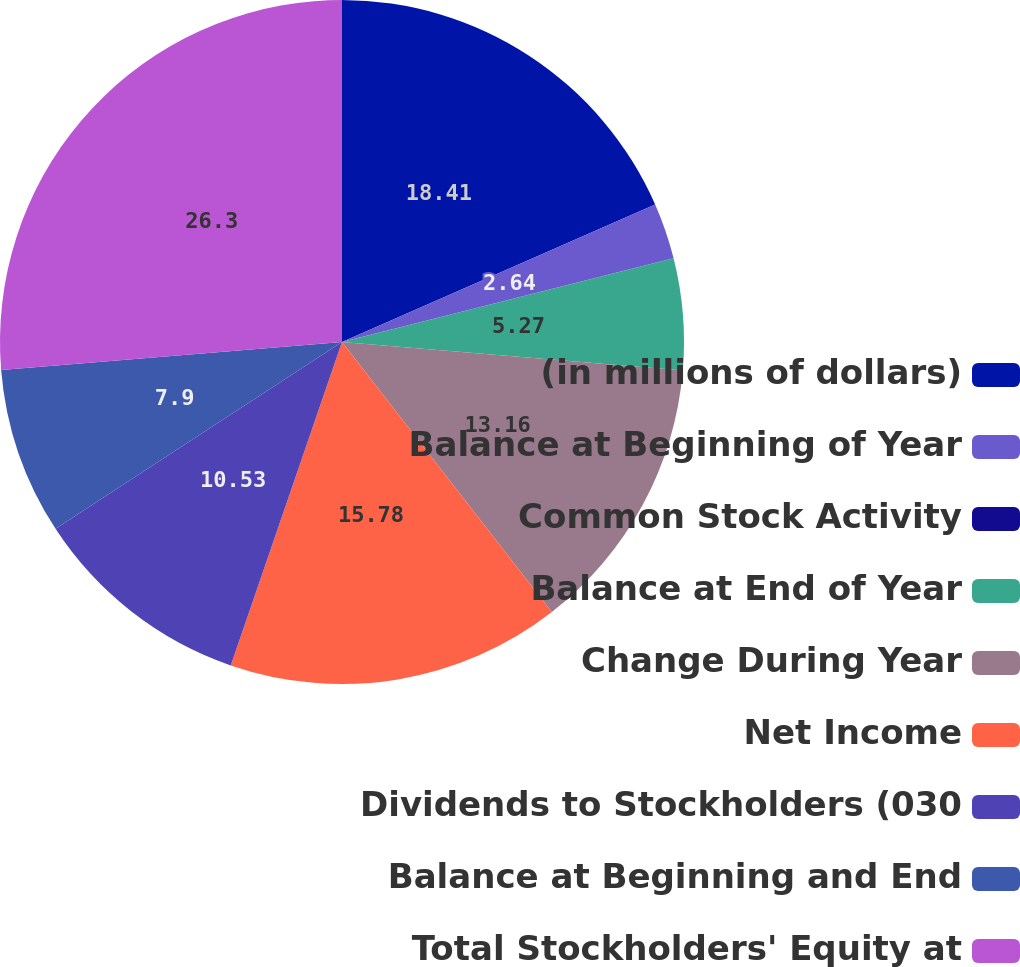<chart> <loc_0><loc_0><loc_500><loc_500><pie_chart><fcel>(in millions of dollars)<fcel>Balance at Beginning of Year<fcel>Common Stock Activity<fcel>Balance at End of Year<fcel>Change During Year<fcel>Net Income<fcel>Dividends to Stockholders (030<fcel>Balance at Beginning and End<fcel>Total Stockholders' Equity at<nl><fcel>18.42%<fcel>2.64%<fcel>0.01%<fcel>5.27%<fcel>13.16%<fcel>15.79%<fcel>10.53%<fcel>7.9%<fcel>26.31%<nl></chart> 